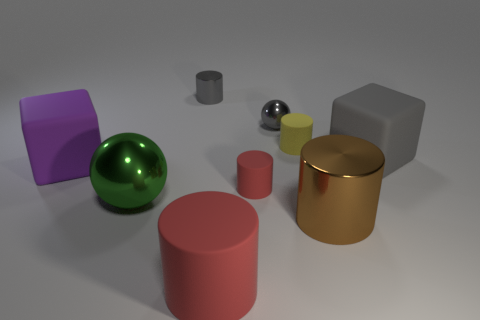Subtract all small rubber cylinders. How many cylinders are left? 3 Subtract all green balls. How many red cylinders are left? 2 Subtract 2 cylinders. How many cylinders are left? 3 Subtract all brown cylinders. How many cylinders are left? 4 Add 1 red matte cubes. How many objects exist? 10 Subtract all gray cylinders. Subtract all cyan cubes. How many cylinders are left? 4 Subtract all balls. How many objects are left? 7 Subtract 1 gray cylinders. How many objects are left? 8 Subtract all large red metallic objects. Subtract all brown cylinders. How many objects are left? 8 Add 2 metallic things. How many metallic things are left? 6 